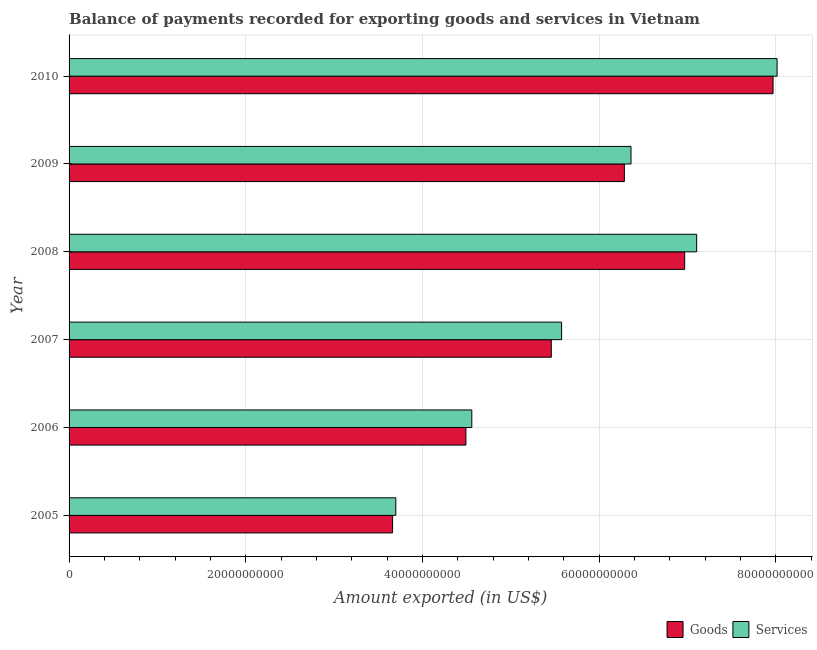Are the number of bars per tick equal to the number of legend labels?
Give a very brief answer. Yes. How many bars are there on the 6th tick from the top?
Ensure brevity in your answer.  2. How many bars are there on the 2nd tick from the bottom?
Provide a short and direct response. 2. What is the label of the 2nd group of bars from the top?
Your response must be concise. 2009. What is the amount of goods exported in 2008?
Offer a terse response. 6.97e+1. Across all years, what is the maximum amount of goods exported?
Make the answer very short. 7.97e+1. Across all years, what is the minimum amount of services exported?
Give a very brief answer. 3.70e+1. In which year was the amount of services exported maximum?
Make the answer very short. 2010. What is the total amount of services exported in the graph?
Provide a succinct answer. 3.53e+11. What is the difference between the amount of goods exported in 2006 and that in 2009?
Your response must be concise. -1.79e+1. What is the difference between the amount of services exported in 2006 and the amount of goods exported in 2010?
Ensure brevity in your answer.  -3.41e+1. What is the average amount of services exported per year?
Your answer should be very brief. 5.89e+1. In the year 2007, what is the difference between the amount of services exported and amount of goods exported?
Make the answer very short. 1.17e+09. In how many years, is the amount of goods exported greater than 60000000000 US$?
Keep it short and to the point. 3. What is the ratio of the amount of services exported in 2006 to that in 2008?
Provide a succinct answer. 0.64. Is the amount of goods exported in 2009 less than that in 2010?
Your response must be concise. Yes. What is the difference between the highest and the second highest amount of services exported?
Keep it short and to the point. 9.10e+09. What is the difference between the highest and the lowest amount of goods exported?
Offer a terse response. 4.31e+1. What does the 2nd bar from the top in 2005 represents?
Give a very brief answer. Goods. What does the 1st bar from the bottom in 2008 represents?
Your answer should be compact. Goods. How many bars are there?
Your answer should be very brief. 12. Are the values on the major ticks of X-axis written in scientific E-notation?
Keep it short and to the point. No. Does the graph contain any zero values?
Offer a very short reply. No. Does the graph contain grids?
Your response must be concise. Yes. How are the legend labels stacked?
Keep it short and to the point. Horizontal. What is the title of the graph?
Your response must be concise. Balance of payments recorded for exporting goods and services in Vietnam. Does "Commercial service imports" appear as one of the legend labels in the graph?
Ensure brevity in your answer.  No. What is the label or title of the X-axis?
Your answer should be very brief. Amount exported (in US$). What is the label or title of the Y-axis?
Your answer should be very brief. Year. What is the Amount exported (in US$) of Goods in 2005?
Provide a succinct answer. 3.66e+1. What is the Amount exported (in US$) in Services in 2005?
Keep it short and to the point. 3.70e+1. What is the Amount exported (in US$) of Goods in 2006?
Keep it short and to the point. 4.49e+1. What is the Amount exported (in US$) in Services in 2006?
Give a very brief answer. 4.56e+1. What is the Amount exported (in US$) of Goods in 2007?
Your answer should be very brief. 5.46e+1. What is the Amount exported (in US$) in Services in 2007?
Make the answer very short. 5.58e+1. What is the Amount exported (in US$) of Goods in 2008?
Your response must be concise. 6.97e+1. What is the Amount exported (in US$) of Services in 2008?
Ensure brevity in your answer.  7.10e+1. What is the Amount exported (in US$) of Goods in 2009?
Give a very brief answer. 6.29e+1. What is the Amount exported (in US$) in Services in 2009?
Give a very brief answer. 6.36e+1. What is the Amount exported (in US$) of Goods in 2010?
Provide a short and direct response. 7.97e+1. What is the Amount exported (in US$) of Services in 2010?
Make the answer very short. 8.02e+1. Across all years, what is the maximum Amount exported (in US$) in Goods?
Your response must be concise. 7.97e+1. Across all years, what is the maximum Amount exported (in US$) in Services?
Offer a terse response. 8.02e+1. Across all years, what is the minimum Amount exported (in US$) of Goods?
Offer a terse response. 3.66e+1. Across all years, what is the minimum Amount exported (in US$) in Services?
Your answer should be very brief. 3.70e+1. What is the total Amount exported (in US$) in Goods in the graph?
Provide a succinct answer. 3.48e+11. What is the total Amount exported (in US$) of Services in the graph?
Provide a succinct answer. 3.53e+11. What is the difference between the Amount exported (in US$) of Goods in 2005 and that in 2006?
Your answer should be compact. -8.30e+09. What is the difference between the Amount exported (in US$) in Services in 2005 and that in 2006?
Ensure brevity in your answer.  -8.61e+09. What is the difference between the Amount exported (in US$) in Goods in 2005 and that in 2007?
Ensure brevity in your answer.  -1.80e+1. What is the difference between the Amount exported (in US$) of Services in 2005 and that in 2007?
Your response must be concise. -1.88e+1. What is the difference between the Amount exported (in US$) of Goods in 2005 and that in 2008?
Provide a short and direct response. -3.31e+1. What is the difference between the Amount exported (in US$) of Services in 2005 and that in 2008?
Your answer should be very brief. -3.41e+1. What is the difference between the Amount exported (in US$) in Goods in 2005 and that in 2009?
Keep it short and to the point. -2.62e+1. What is the difference between the Amount exported (in US$) of Services in 2005 and that in 2009?
Your answer should be compact. -2.66e+1. What is the difference between the Amount exported (in US$) of Goods in 2005 and that in 2010?
Offer a terse response. -4.31e+1. What is the difference between the Amount exported (in US$) of Services in 2005 and that in 2010?
Make the answer very short. -4.32e+1. What is the difference between the Amount exported (in US$) in Goods in 2006 and that in 2007?
Make the answer very short. -9.66e+09. What is the difference between the Amount exported (in US$) of Services in 2006 and that in 2007?
Your answer should be very brief. -1.02e+1. What is the difference between the Amount exported (in US$) of Goods in 2006 and that in 2008?
Keep it short and to the point. -2.48e+1. What is the difference between the Amount exported (in US$) of Services in 2006 and that in 2008?
Ensure brevity in your answer.  -2.55e+1. What is the difference between the Amount exported (in US$) of Goods in 2006 and that in 2009?
Provide a short and direct response. -1.79e+1. What is the difference between the Amount exported (in US$) of Services in 2006 and that in 2009?
Your response must be concise. -1.80e+1. What is the difference between the Amount exported (in US$) in Goods in 2006 and that in 2010?
Offer a terse response. -3.48e+1. What is the difference between the Amount exported (in US$) in Services in 2006 and that in 2010?
Offer a very short reply. -3.46e+1. What is the difference between the Amount exported (in US$) in Goods in 2007 and that in 2008?
Provide a short and direct response. -1.51e+1. What is the difference between the Amount exported (in US$) of Services in 2007 and that in 2008?
Ensure brevity in your answer.  -1.53e+1. What is the difference between the Amount exported (in US$) in Goods in 2007 and that in 2009?
Your answer should be very brief. -8.27e+09. What is the difference between the Amount exported (in US$) of Services in 2007 and that in 2009?
Your answer should be very brief. -7.86e+09. What is the difference between the Amount exported (in US$) of Goods in 2007 and that in 2010?
Offer a very short reply. -2.51e+1. What is the difference between the Amount exported (in US$) in Services in 2007 and that in 2010?
Provide a short and direct response. -2.44e+1. What is the difference between the Amount exported (in US$) of Goods in 2008 and that in 2009?
Your answer should be compact. 6.83e+09. What is the difference between the Amount exported (in US$) of Services in 2008 and that in 2009?
Your answer should be compact. 7.43e+09. What is the difference between the Amount exported (in US$) in Goods in 2008 and that in 2010?
Provide a succinct answer. -1.00e+1. What is the difference between the Amount exported (in US$) of Services in 2008 and that in 2010?
Make the answer very short. -9.10e+09. What is the difference between the Amount exported (in US$) of Goods in 2009 and that in 2010?
Your response must be concise. -1.68e+1. What is the difference between the Amount exported (in US$) in Services in 2009 and that in 2010?
Offer a terse response. -1.65e+1. What is the difference between the Amount exported (in US$) in Goods in 2005 and the Amount exported (in US$) in Services in 2006?
Make the answer very short. -8.97e+09. What is the difference between the Amount exported (in US$) of Goods in 2005 and the Amount exported (in US$) of Services in 2007?
Give a very brief answer. -1.91e+1. What is the difference between the Amount exported (in US$) in Goods in 2005 and the Amount exported (in US$) in Services in 2008?
Your response must be concise. -3.44e+1. What is the difference between the Amount exported (in US$) of Goods in 2005 and the Amount exported (in US$) of Services in 2009?
Keep it short and to the point. -2.70e+1. What is the difference between the Amount exported (in US$) of Goods in 2005 and the Amount exported (in US$) of Services in 2010?
Provide a short and direct response. -4.35e+1. What is the difference between the Amount exported (in US$) of Goods in 2006 and the Amount exported (in US$) of Services in 2007?
Your answer should be compact. -1.08e+1. What is the difference between the Amount exported (in US$) of Goods in 2006 and the Amount exported (in US$) of Services in 2008?
Keep it short and to the point. -2.61e+1. What is the difference between the Amount exported (in US$) of Goods in 2006 and the Amount exported (in US$) of Services in 2009?
Your answer should be compact. -1.87e+1. What is the difference between the Amount exported (in US$) in Goods in 2006 and the Amount exported (in US$) in Services in 2010?
Your answer should be very brief. -3.52e+1. What is the difference between the Amount exported (in US$) of Goods in 2007 and the Amount exported (in US$) of Services in 2008?
Your answer should be compact. -1.65e+1. What is the difference between the Amount exported (in US$) in Goods in 2007 and the Amount exported (in US$) in Services in 2009?
Give a very brief answer. -9.02e+09. What is the difference between the Amount exported (in US$) in Goods in 2007 and the Amount exported (in US$) in Services in 2010?
Give a very brief answer. -2.56e+1. What is the difference between the Amount exported (in US$) of Goods in 2008 and the Amount exported (in US$) of Services in 2009?
Ensure brevity in your answer.  6.08e+09. What is the difference between the Amount exported (in US$) of Goods in 2008 and the Amount exported (in US$) of Services in 2010?
Make the answer very short. -1.05e+1. What is the difference between the Amount exported (in US$) in Goods in 2009 and the Amount exported (in US$) in Services in 2010?
Your response must be concise. -1.73e+1. What is the average Amount exported (in US$) in Goods per year?
Offer a very short reply. 5.81e+1. What is the average Amount exported (in US$) in Services per year?
Your response must be concise. 5.89e+1. In the year 2005, what is the difference between the Amount exported (in US$) of Goods and Amount exported (in US$) of Services?
Your answer should be very brief. -3.64e+08. In the year 2006, what is the difference between the Amount exported (in US$) of Goods and Amount exported (in US$) of Services?
Ensure brevity in your answer.  -6.68e+08. In the year 2007, what is the difference between the Amount exported (in US$) of Goods and Amount exported (in US$) of Services?
Your answer should be compact. -1.17e+09. In the year 2008, what is the difference between the Amount exported (in US$) in Goods and Amount exported (in US$) in Services?
Provide a short and direct response. -1.36e+09. In the year 2009, what is the difference between the Amount exported (in US$) of Goods and Amount exported (in US$) of Services?
Offer a very short reply. -7.53e+08. In the year 2010, what is the difference between the Amount exported (in US$) of Goods and Amount exported (in US$) of Services?
Offer a very short reply. -4.56e+08. What is the ratio of the Amount exported (in US$) of Goods in 2005 to that in 2006?
Your response must be concise. 0.82. What is the ratio of the Amount exported (in US$) in Services in 2005 to that in 2006?
Your response must be concise. 0.81. What is the ratio of the Amount exported (in US$) in Goods in 2005 to that in 2007?
Offer a terse response. 0.67. What is the ratio of the Amount exported (in US$) of Services in 2005 to that in 2007?
Make the answer very short. 0.66. What is the ratio of the Amount exported (in US$) of Goods in 2005 to that in 2008?
Give a very brief answer. 0.53. What is the ratio of the Amount exported (in US$) of Services in 2005 to that in 2008?
Make the answer very short. 0.52. What is the ratio of the Amount exported (in US$) in Goods in 2005 to that in 2009?
Your answer should be compact. 0.58. What is the ratio of the Amount exported (in US$) of Services in 2005 to that in 2009?
Provide a short and direct response. 0.58. What is the ratio of the Amount exported (in US$) in Goods in 2005 to that in 2010?
Keep it short and to the point. 0.46. What is the ratio of the Amount exported (in US$) in Services in 2005 to that in 2010?
Offer a very short reply. 0.46. What is the ratio of the Amount exported (in US$) in Goods in 2006 to that in 2007?
Keep it short and to the point. 0.82. What is the ratio of the Amount exported (in US$) of Services in 2006 to that in 2007?
Your response must be concise. 0.82. What is the ratio of the Amount exported (in US$) of Goods in 2006 to that in 2008?
Keep it short and to the point. 0.64. What is the ratio of the Amount exported (in US$) of Services in 2006 to that in 2008?
Provide a succinct answer. 0.64. What is the ratio of the Amount exported (in US$) of Goods in 2006 to that in 2009?
Ensure brevity in your answer.  0.71. What is the ratio of the Amount exported (in US$) of Services in 2006 to that in 2009?
Offer a terse response. 0.72. What is the ratio of the Amount exported (in US$) in Goods in 2006 to that in 2010?
Offer a terse response. 0.56. What is the ratio of the Amount exported (in US$) of Services in 2006 to that in 2010?
Your answer should be very brief. 0.57. What is the ratio of the Amount exported (in US$) in Goods in 2007 to that in 2008?
Give a very brief answer. 0.78. What is the ratio of the Amount exported (in US$) in Services in 2007 to that in 2008?
Your response must be concise. 0.78. What is the ratio of the Amount exported (in US$) of Goods in 2007 to that in 2009?
Make the answer very short. 0.87. What is the ratio of the Amount exported (in US$) in Services in 2007 to that in 2009?
Keep it short and to the point. 0.88. What is the ratio of the Amount exported (in US$) in Goods in 2007 to that in 2010?
Your response must be concise. 0.69. What is the ratio of the Amount exported (in US$) in Services in 2007 to that in 2010?
Your response must be concise. 0.7. What is the ratio of the Amount exported (in US$) in Goods in 2008 to that in 2009?
Make the answer very short. 1.11. What is the ratio of the Amount exported (in US$) in Services in 2008 to that in 2009?
Keep it short and to the point. 1.12. What is the ratio of the Amount exported (in US$) in Goods in 2008 to that in 2010?
Offer a terse response. 0.87. What is the ratio of the Amount exported (in US$) of Services in 2008 to that in 2010?
Make the answer very short. 0.89. What is the ratio of the Amount exported (in US$) of Goods in 2009 to that in 2010?
Your response must be concise. 0.79. What is the ratio of the Amount exported (in US$) of Services in 2009 to that in 2010?
Ensure brevity in your answer.  0.79. What is the difference between the highest and the second highest Amount exported (in US$) in Goods?
Make the answer very short. 1.00e+1. What is the difference between the highest and the second highest Amount exported (in US$) in Services?
Your answer should be very brief. 9.10e+09. What is the difference between the highest and the lowest Amount exported (in US$) of Goods?
Your answer should be compact. 4.31e+1. What is the difference between the highest and the lowest Amount exported (in US$) in Services?
Your answer should be compact. 4.32e+1. 